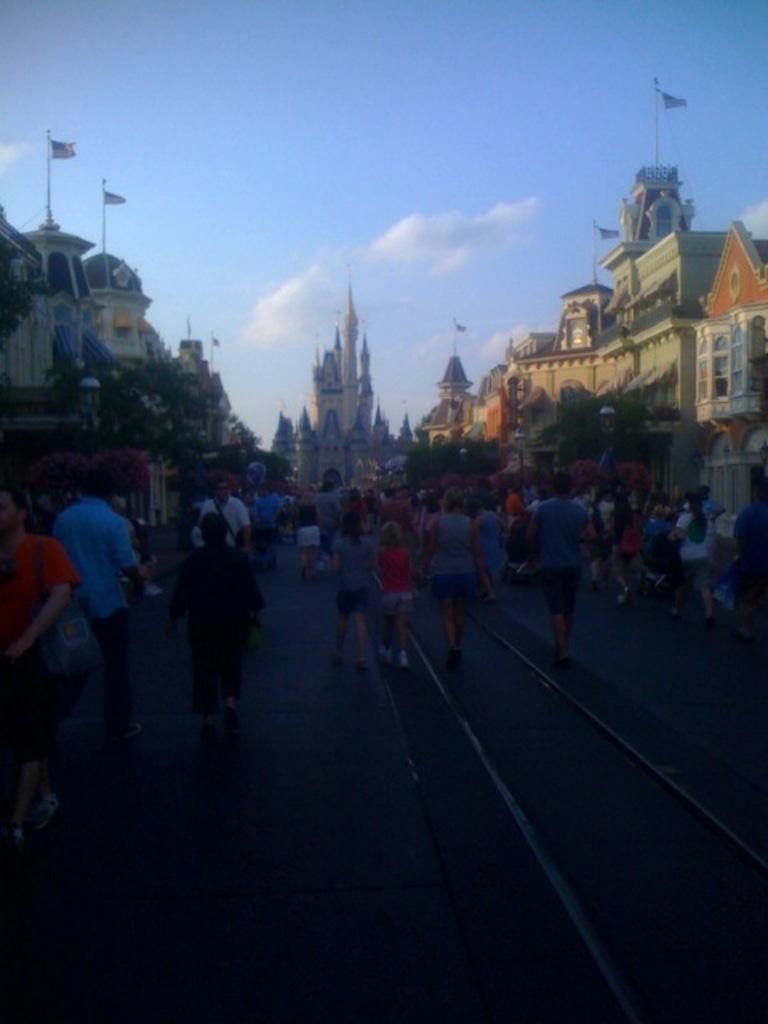Please provide a concise description of this image. In this image we can see a group of persons. Behind the persons we can see the buildings. At the top we can see the sky 